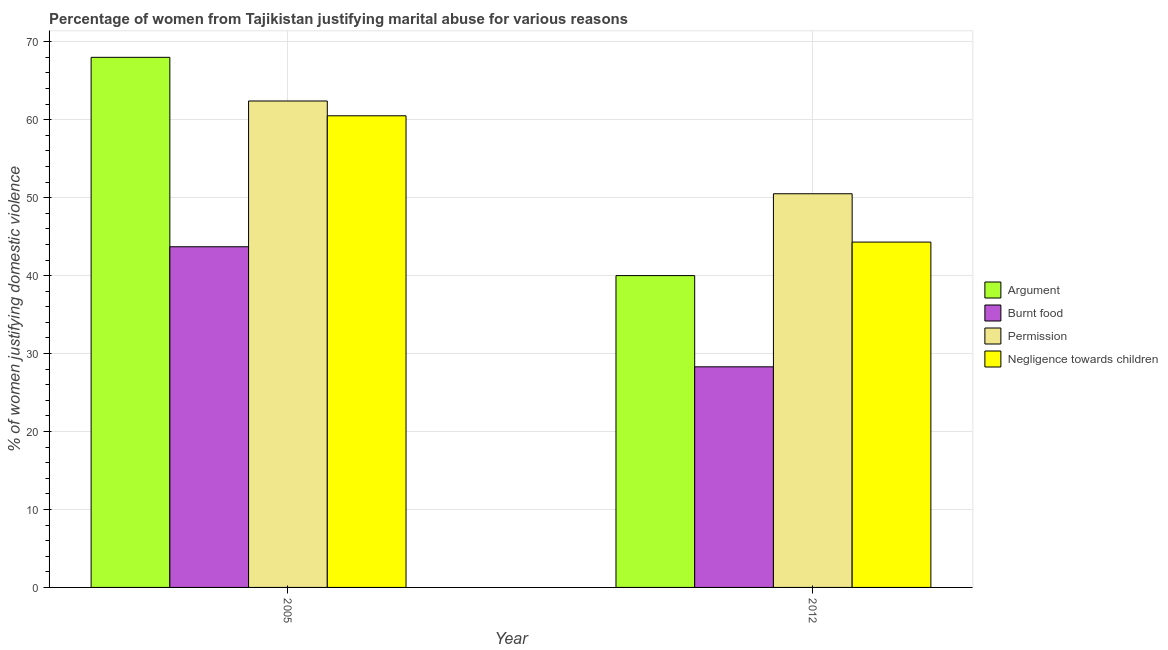How many different coloured bars are there?
Provide a succinct answer. 4. How many groups of bars are there?
Offer a very short reply. 2. In how many cases, is the number of bars for a given year not equal to the number of legend labels?
Provide a succinct answer. 0. What is the percentage of women justifying abuse for showing negligence towards children in 2012?
Your answer should be compact. 44.3. Across all years, what is the maximum percentage of women justifying abuse for showing negligence towards children?
Offer a very short reply. 60.5. Across all years, what is the minimum percentage of women justifying abuse for going without permission?
Keep it short and to the point. 50.5. What is the total percentage of women justifying abuse in the case of an argument in the graph?
Provide a short and direct response. 108. What is the difference between the percentage of women justifying abuse for showing negligence towards children in 2005 and that in 2012?
Give a very brief answer. 16.2. What is the difference between the percentage of women justifying abuse for going without permission in 2005 and the percentage of women justifying abuse for showing negligence towards children in 2012?
Make the answer very short. 11.9. What is the average percentage of women justifying abuse for showing negligence towards children per year?
Your answer should be very brief. 52.4. In the year 2012, what is the difference between the percentage of women justifying abuse for showing negligence towards children and percentage of women justifying abuse for going without permission?
Your answer should be compact. 0. What is the ratio of the percentage of women justifying abuse for burning food in 2005 to that in 2012?
Your response must be concise. 1.54. What does the 2nd bar from the left in 2005 represents?
Offer a very short reply. Burnt food. What does the 2nd bar from the right in 2005 represents?
Provide a short and direct response. Permission. Is it the case that in every year, the sum of the percentage of women justifying abuse in the case of an argument and percentage of women justifying abuse for burning food is greater than the percentage of women justifying abuse for going without permission?
Your answer should be very brief. Yes. How many years are there in the graph?
Offer a terse response. 2. What is the difference between two consecutive major ticks on the Y-axis?
Your answer should be compact. 10. Are the values on the major ticks of Y-axis written in scientific E-notation?
Your response must be concise. No. Does the graph contain any zero values?
Offer a terse response. No. Where does the legend appear in the graph?
Your response must be concise. Center right. How many legend labels are there?
Give a very brief answer. 4. What is the title of the graph?
Keep it short and to the point. Percentage of women from Tajikistan justifying marital abuse for various reasons. Does "UNPBF" appear as one of the legend labels in the graph?
Your answer should be very brief. No. What is the label or title of the X-axis?
Your response must be concise. Year. What is the label or title of the Y-axis?
Your answer should be compact. % of women justifying domestic violence. What is the % of women justifying domestic violence of Burnt food in 2005?
Provide a short and direct response. 43.7. What is the % of women justifying domestic violence in Permission in 2005?
Your answer should be very brief. 62.4. What is the % of women justifying domestic violence of Negligence towards children in 2005?
Provide a short and direct response. 60.5. What is the % of women justifying domestic violence in Burnt food in 2012?
Keep it short and to the point. 28.3. What is the % of women justifying domestic violence in Permission in 2012?
Ensure brevity in your answer.  50.5. What is the % of women justifying domestic violence of Negligence towards children in 2012?
Offer a very short reply. 44.3. Across all years, what is the maximum % of women justifying domestic violence in Burnt food?
Provide a succinct answer. 43.7. Across all years, what is the maximum % of women justifying domestic violence of Permission?
Keep it short and to the point. 62.4. Across all years, what is the maximum % of women justifying domestic violence of Negligence towards children?
Offer a terse response. 60.5. Across all years, what is the minimum % of women justifying domestic violence in Argument?
Offer a terse response. 40. Across all years, what is the minimum % of women justifying domestic violence in Burnt food?
Give a very brief answer. 28.3. Across all years, what is the minimum % of women justifying domestic violence in Permission?
Ensure brevity in your answer.  50.5. Across all years, what is the minimum % of women justifying domestic violence of Negligence towards children?
Offer a terse response. 44.3. What is the total % of women justifying domestic violence in Argument in the graph?
Your response must be concise. 108. What is the total % of women justifying domestic violence in Burnt food in the graph?
Offer a very short reply. 72. What is the total % of women justifying domestic violence in Permission in the graph?
Your answer should be compact. 112.9. What is the total % of women justifying domestic violence in Negligence towards children in the graph?
Your answer should be compact. 104.8. What is the difference between the % of women justifying domestic violence of Argument in 2005 and that in 2012?
Your answer should be compact. 28. What is the difference between the % of women justifying domestic violence of Burnt food in 2005 and that in 2012?
Your answer should be compact. 15.4. What is the difference between the % of women justifying domestic violence of Argument in 2005 and the % of women justifying domestic violence of Burnt food in 2012?
Offer a very short reply. 39.7. What is the difference between the % of women justifying domestic violence of Argument in 2005 and the % of women justifying domestic violence of Permission in 2012?
Your answer should be very brief. 17.5. What is the difference between the % of women justifying domestic violence of Argument in 2005 and the % of women justifying domestic violence of Negligence towards children in 2012?
Provide a succinct answer. 23.7. What is the difference between the % of women justifying domestic violence in Burnt food in 2005 and the % of women justifying domestic violence in Permission in 2012?
Provide a succinct answer. -6.8. What is the difference between the % of women justifying domestic violence in Burnt food in 2005 and the % of women justifying domestic violence in Negligence towards children in 2012?
Provide a short and direct response. -0.6. What is the difference between the % of women justifying domestic violence in Permission in 2005 and the % of women justifying domestic violence in Negligence towards children in 2012?
Keep it short and to the point. 18.1. What is the average % of women justifying domestic violence in Argument per year?
Give a very brief answer. 54. What is the average % of women justifying domestic violence of Permission per year?
Your response must be concise. 56.45. What is the average % of women justifying domestic violence in Negligence towards children per year?
Ensure brevity in your answer.  52.4. In the year 2005, what is the difference between the % of women justifying domestic violence in Argument and % of women justifying domestic violence in Burnt food?
Your answer should be compact. 24.3. In the year 2005, what is the difference between the % of women justifying domestic violence in Argument and % of women justifying domestic violence in Permission?
Your answer should be compact. 5.6. In the year 2005, what is the difference between the % of women justifying domestic violence of Argument and % of women justifying domestic violence of Negligence towards children?
Provide a succinct answer. 7.5. In the year 2005, what is the difference between the % of women justifying domestic violence of Burnt food and % of women justifying domestic violence of Permission?
Ensure brevity in your answer.  -18.7. In the year 2005, what is the difference between the % of women justifying domestic violence in Burnt food and % of women justifying domestic violence in Negligence towards children?
Provide a short and direct response. -16.8. In the year 2005, what is the difference between the % of women justifying domestic violence of Permission and % of women justifying domestic violence of Negligence towards children?
Your answer should be very brief. 1.9. In the year 2012, what is the difference between the % of women justifying domestic violence of Argument and % of women justifying domestic violence of Permission?
Offer a terse response. -10.5. In the year 2012, what is the difference between the % of women justifying domestic violence of Burnt food and % of women justifying domestic violence of Permission?
Keep it short and to the point. -22.2. In the year 2012, what is the difference between the % of women justifying domestic violence of Burnt food and % of women justifying domestic violence of Negligence towards children?
Ensure brevity in your answer.  -16. What is the ratio of the % of women justifying domestic violence in Burnt food in 2005 to that in 2012?
Your answer should be very brief. 1.54. What is the ratio of the % of women justifying domestic violence in Permission in 2005 to that in 2012?
Your answer should be compact. 1.24. What is the ratio of the % of women justifying domestic violence in Negligence towards children in 2005 to that in 2012?
Provide a short and direct response. 1.37. What is the difference between the highest and the second highest % of women justifying domestic violence in Argument?
Your answer should be very brief. 28. What is the difference between the highest and the second highest % of women justifying domestic violence of Permission?
Offer a very short reply. 11.9. What is the difference between the highest and the second highest % of women justifying domestic violence in Negligence towards children?
Ensure brevity in your answer.  16.2. What is the difference between the highest and the lowest % of women justifying domestic violence of Burnt food?
Make the answer very short. 15.4. What is the difference between the highest and the lowest % of women justifying domestic violence in Permission?
Make the answer very short. 11.9. 